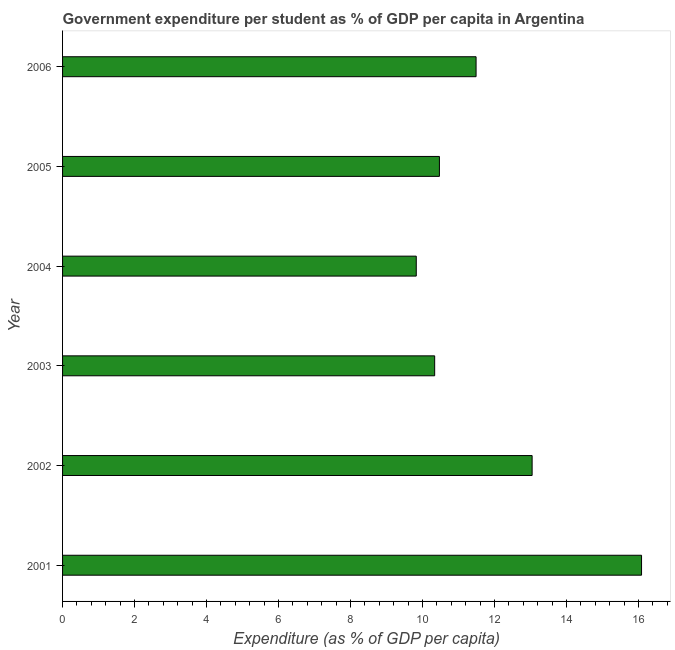What is the title of the graph?
Provide a succinct answer. Government expenditure per student as % of GDP per capita in Argentina. What is the label or title of the X-axis?
Your answer should be compact. Expenditure (as % of GDP per capita). What is the label or title of the Y-axis?
Provide a succinct answer. Year. What is the government expenditure per student in 2003?
Your answer should be very brief. 10.34. Across all years, what is the maximum government expenditure per student?
Provide a succinct answer. 16.09. Across all years, what is the minimum government expenditure per student?
Provide a succinct answer. 9.83. In which year was the government expenditure per student minimum?
Provide a short and direct response. 2004. What is the sum of the government expenditure per student?
Your answer should be very brief. 71.26. What is the difference between the government expenditure per student in 2002 and 2003?
Give a very brief answer. 2.71. What is the average government expenditure per student per year?
Your answer should be compact. 11.88. What is the median government expenditure per student?
Provide a succinct answer. 10.98. Do a majority of the years between 2002 and 2004 (inclusive) have government expenditure per student greater than 1.6 %?
Your answer should be compact. Yes. What is the ratio of the government expenditure per student in 2001 to that in 2006?
Make the answer very short. 1.4. Is the government expenditure per student in 2005 less than that in 2006?
Make the answer very short. Yes. What is the difference between the highest and the second highest government expenditure per student?
Your answer should be very brief. 3.04. What is the difference between the highest and the lowest government expenditure per student?
Give a very brief answer. 6.26. What is the difference between two consecutive major ticks on the X-axis?
Your answer should be compact. 2. What is the Expenditure (as % of GDP per capita) in 2001?
Make the answer very short. 16.09. What is the Expenditure (as % of GDP per capita) of 2002?
Provide a short and direct response. 13.05. What is the Expenditure (as % of GDP per capita) of 2003?
Keep it short and to the point. 10.34. What is the Expenditure (as % of GDP per capita) of 2004?
Provide a short and direct response. 9.83. What is the Expenditure (as % of GDP per capita) in 2005?
Your answer should be compact. 10.47. What is the Expenditure (as % of GDP per capita) in 2006?
Keep it short and to the point. 11.49. What is the difference between the Expenditure (as % of GDP per capita) in 2001 and 2002?
Provide a succinct answer. 3.04. What is the difference between the Expenditure (as % of GDP per capita) in 2001 and 2003?
Keep it short and to the point. 5.75. What is the difference between the Expenditure (as % of GDP per capita) in 2001 and 2004?
Make the answer very short. 6.26. What is the difference between the Expenditure (as % of GDP per capita) in 2001 and 2005?
Offer a terse response. 5.62. What is the difference between the Expenditure (as % of GDP per capita) in 2001 and 2006?
Offer a very short reply. 4.6. What is the difference between the Expenditure (as % of GDP per capita) in 2002 and 2003?
Make the answer very short. 2.71. What is the difference between the Expenditure (as % of GDP per capita) in 2002 and 2004?
Ensure brevity in your answer.  3.22. What is the difference between the Expenditure (as % of GDP per capita) in 2002 and 2005?
Your response must be concise. 2.58. What is the difference between the Expenditure (as % of GDP per capita) in 2002 and 2006?
Offer a terse response. 1.56. What is the difference between the Expenditure (as % of GDP per capita) in 2003 and 2004?
Make the answer very short. 0.51. What is the difference between the Expenditure (as % of GDP per capita) in 2003 and 2005?
Your response must be concise. -0.13. What is the difference between the Expenditure (as % of GDP per capita) in 2003 and 2006?
Provide a succinct answer. -1.15. What is the difference between the Expenditure (as % of GDP per capita) in 2004 and 2005?
Provide a succinct answer. -0.64. What is the difference between the Expenditure (as % of GDP per capita) in 2004 and 2006?
Give a very brief answer. -1.66. What is the difference between the Expenditure (as % of GDP per capita) in 2005 and 2006?
Provide a succinct answer. -1.02. What is the ratio of the Expenditure (as % of GDP per capita) in 2001 to that in 2002?
Your answer should be very brief. 1.23. What is the ratio of the Expenditure (as % of GDP per capita) in 2001 to that in 2003?
Your answer should be compact. 1.56. What is the ratio of the Expenditure (as % of GDP per capita) in 2001 to that in 2004?
Give a very brief answer. 1.64. What is the ratio of the Expenditure (as % of GDP per capita) in 2001 to that in 2005?
Ensure brevity in your answer.  1.54. What is the ratio of the Expenditure (as % of GDP per capita) in 2001 to that in 2006?
Your answer should be very brief. 1.4. What is the ratio of the Expenditure (as % of GDP per capita) in 2002 to that in 2003?
Your response must be concise. 1.26. What is the ratio of the Expenditure (as % of GDP per capita) in 2002 to that in 2004?
Ensure brevity in your answer.  1.33. What is the ratio of the Expenditure (as % of GDP per capita) in 2002 to that in 2005?
Provide a short and direct response. 1.25. What is the ratio of the Expenditure (as % of GDP per capita) in 2002 to that in 2006?
Your answer should be compact. 1.14. What is the ratio of the Expenditure (as % of GDP per capita) in 2003 to that in 2004?
Your answer should be very brief. 1.05. What is the ratio of the Expenditure (as % of GDP per capita) in 2003 to that in 2006?
Your answer should be compact. 0.9. What is the ratio of the Expenditure (as % of GDP per capita) in 2004 to that in 2005?
Provide a succinct answer. 0.94. What is the ratio of the Expenditure (as % of GDP per capita) in 2004 to that in 2006?
Offer a terse response. 0.85. What is the ratio of the Expenditure (as % of GDP per capita) in 2005 to that in 2006?
Offer a terse response. 0.91. 